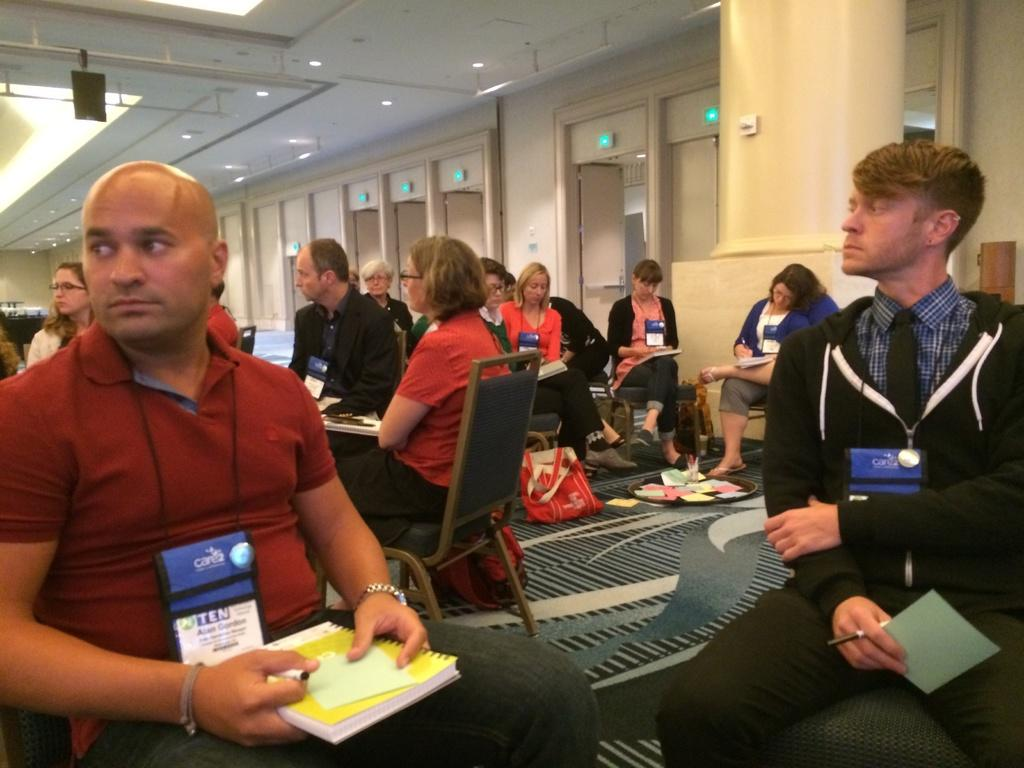What are the people in the image doing? The people in the image are sitting on chairs and holding books and pens. What can be seen in the background of the image? There are doors, a wall, and lights visible in the background of the image. What is on the floor in the image? There are bags on the floor in the image. What type of bee can be seen buzzing around the people in the image? There are no bees present in the image; the people are holding books and pens while sitting on chairs. What tool is the person using to hammer nails in the image? There is no hammer or any indication of hammering in the image; the people are holding books and pens while sitting on chairs. 